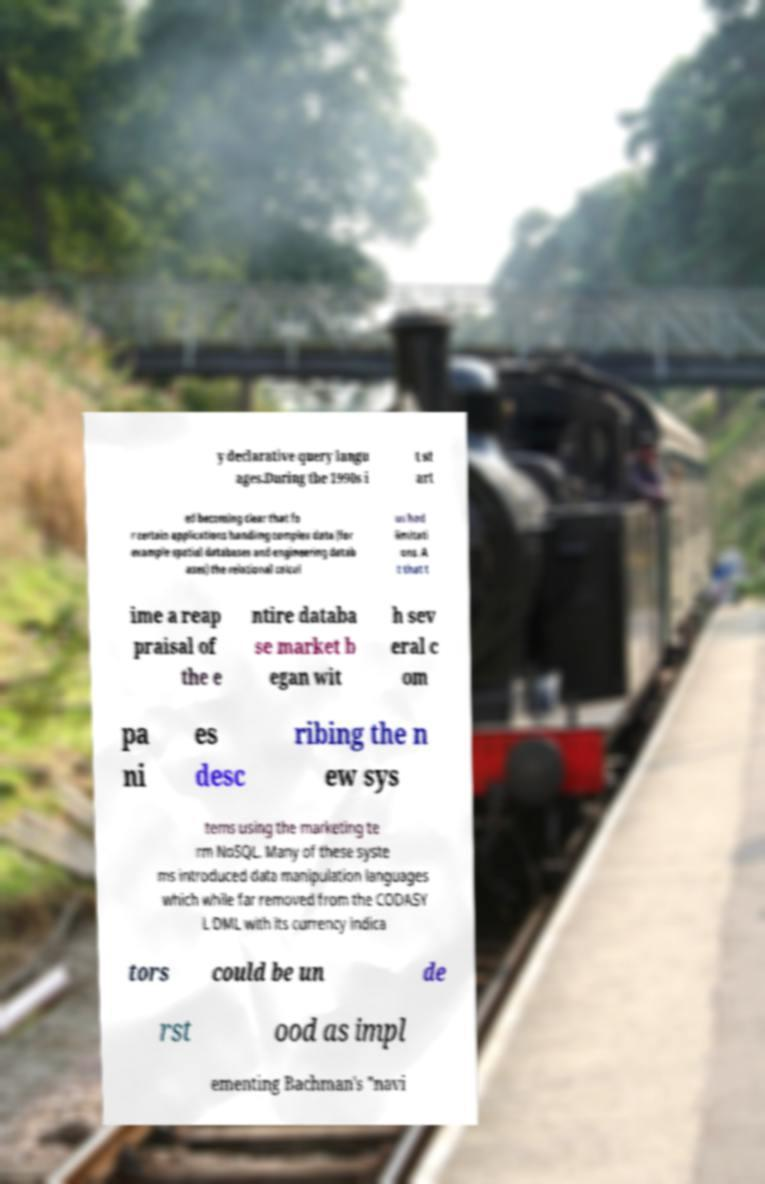What messages or text are displayed in this image? I need them in a readable, typed format. y declarative query langu ages.During the 1990s i t st art ed becoming clear that fo r certain applications handling complex data (for example spatial databases and engineering datab ases) the relational calcul us had limitati ons. A t that t ime a reap praisal of the e ntire databa se market b egan wit h sev eral c om pa ni es desc ribing the n ew sys tems using the marketing te rm NoSQL. Many of these syste ms introduced data manipulation languages which while far removed from the CODASY L DML with its currency indica tors could be un de rst ood as impl ementing Bachman's "navi 